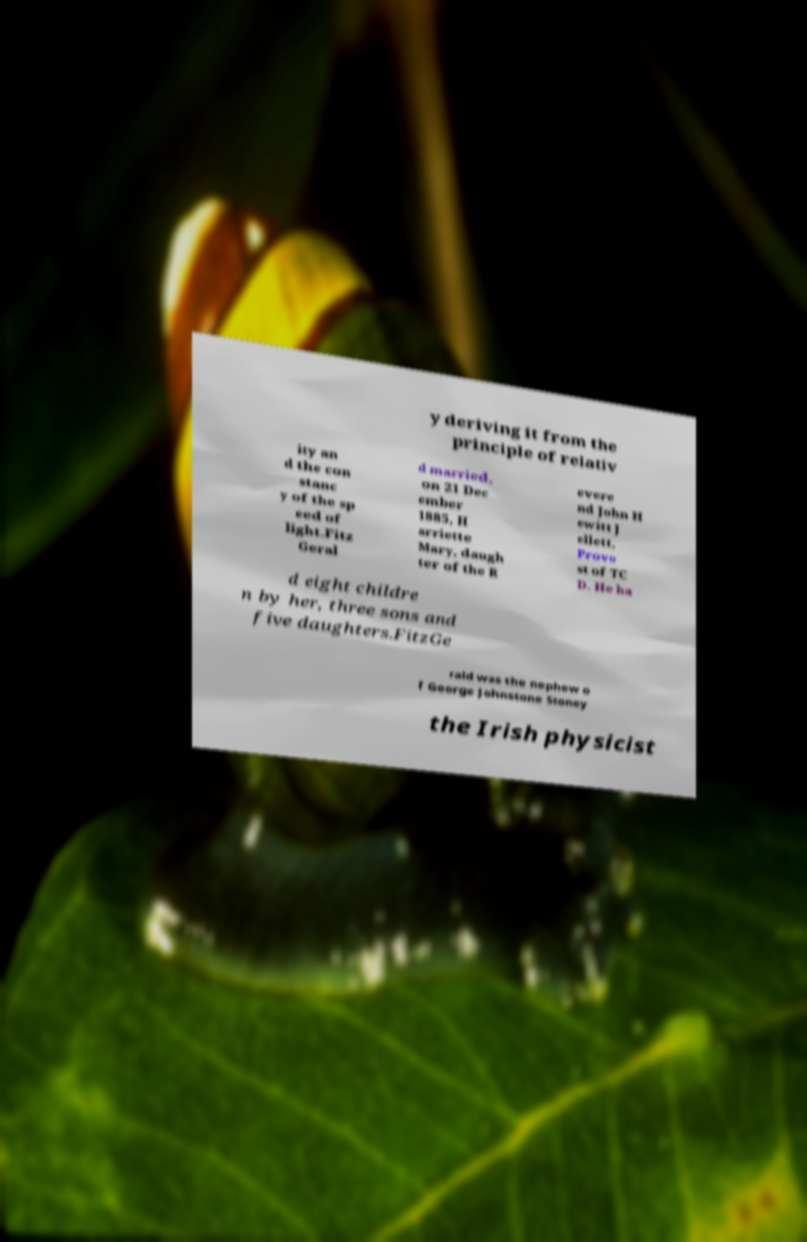What messages or text are displayed in this image? I need them in a readable, typed format. y deriving it from the principle of relativ ity an d the con stanc y of the sp eed of light.Fitz Geral d married, on 21 Dec ember 1885, H arriette Mary, daugh ter of the R evere nd John H ewitt J ellett, Provo st of TC D. He ha d eight childre n by her, three sons and five daughters.FitzGe rald was the nephew o f George Johnstone Stoney the Irish physicist 